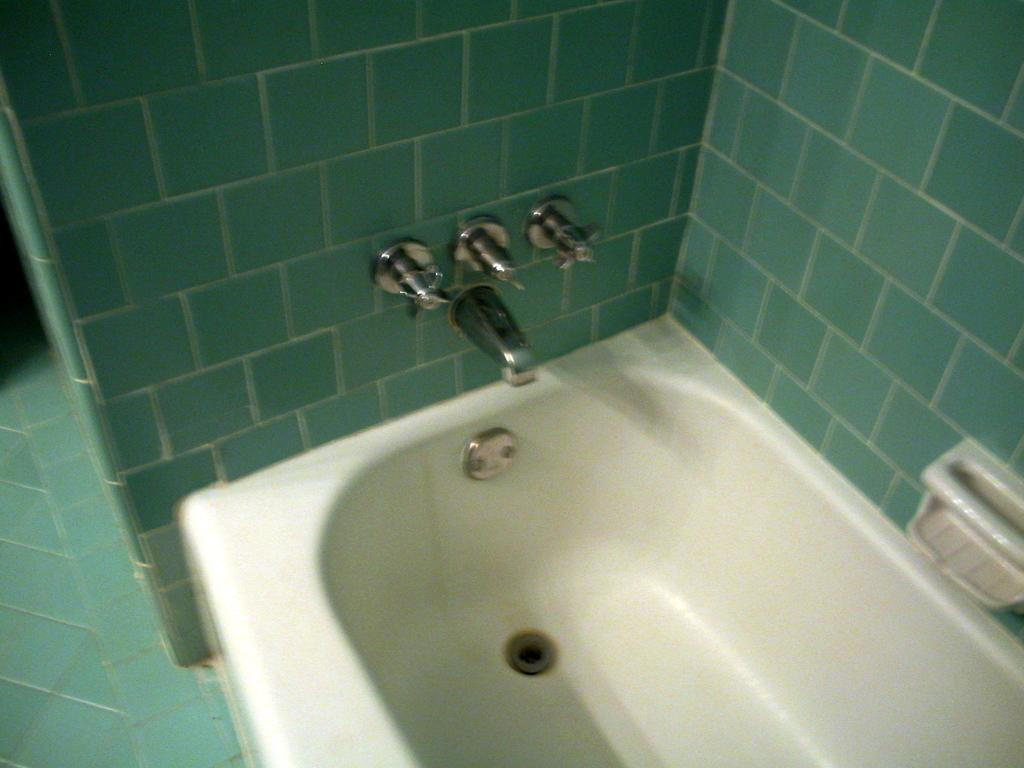What type of fixture is present in the image? There is a sink in the image. What is attached to the sink in the image? There is a tap in the image. What item is used for cleaning hands in the image? There is a soap box in the image. What color are the tiles in the image? The tiles in the image are green in color. What type of cast can be seen on the person's arm in the image? There is no person or cast present in the image; it only features a sink, tap, soap box, and green tiles. How does the digestion process work for the food in the image? There is no food or digestion process present in the image; it only features a sink, tap, soap box, and green tiles. 